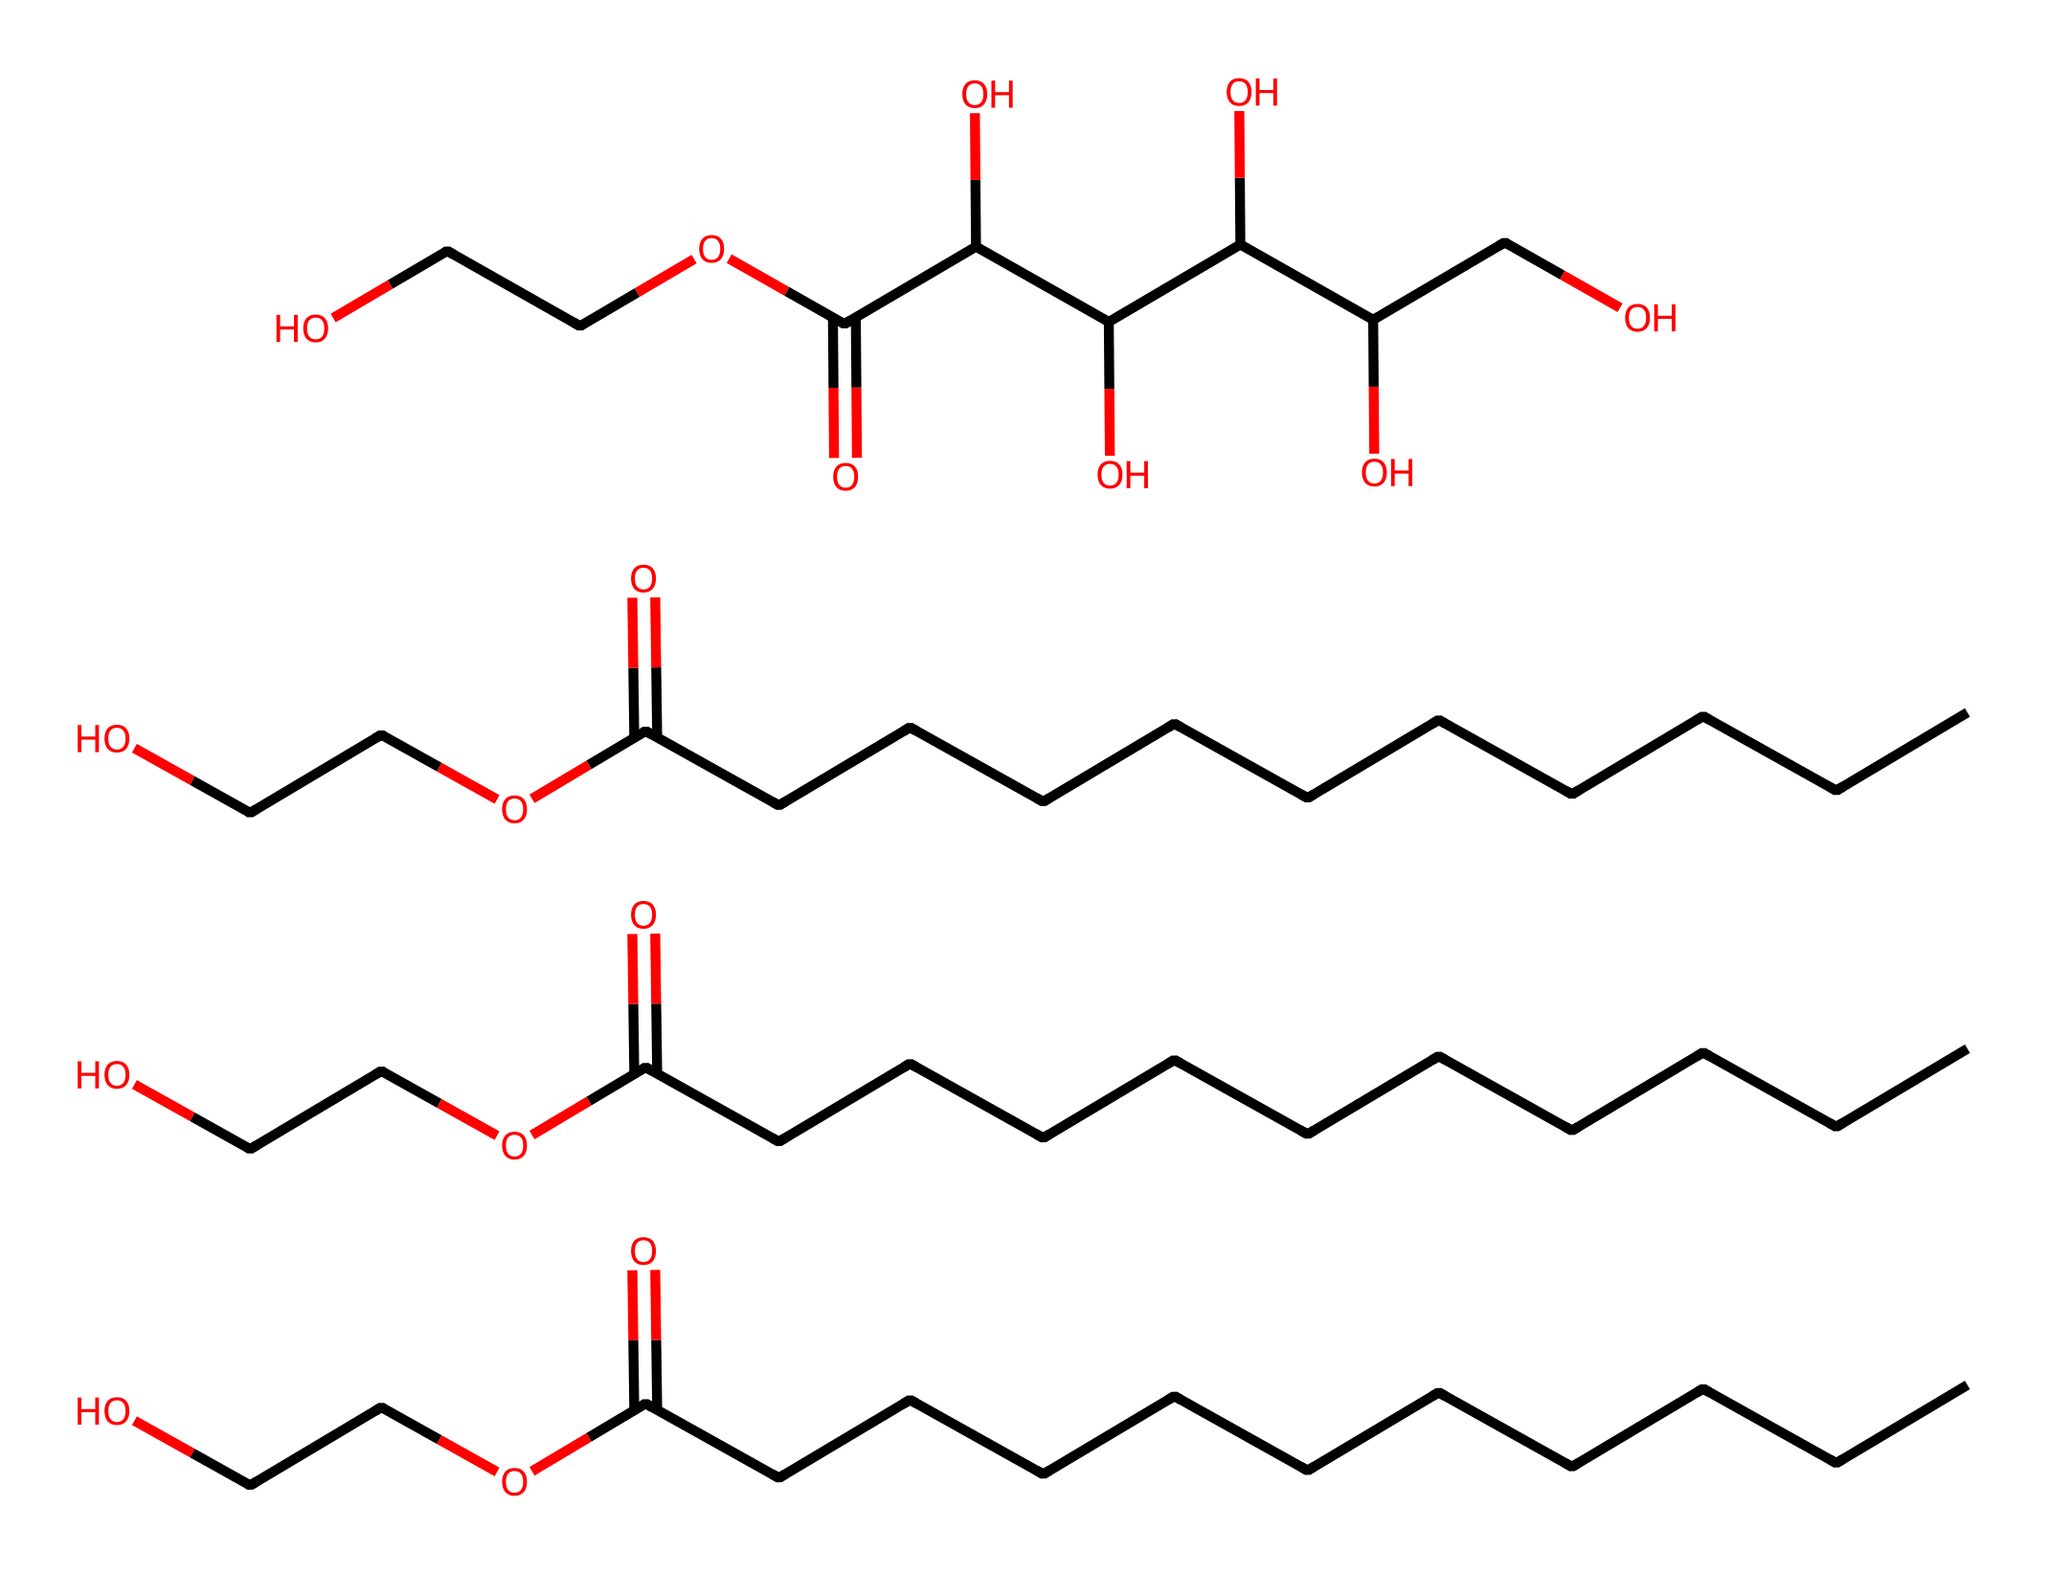What is the molecular formula of polysorbate 20? By interpreting the SMILES representation, we can see that multiple components represent the polysorbate structure. Counting the atoms represented in the structure, we gather that the elemental composition includes carbon, hydrogen, and oxygen. After compiling this information, the molecular formula is determined.
Answer: C58H114O26 How many hydroxyl (–OH) groups are present in this molecule? By analyzing the structure in the SMILES representation, we can identify parts of the molecule where hydroxyl groups are evident, which appear as branching where oxygen is linked to hydrogen atoms. A careful count reveals that there are six distinct hydroxyl groups in this polysorbate structure.
Answer: 6 What type of functional group characterizes polysorbate 20? Since polysorbate 20 is a surfactant, we look for characteristics in the chemical structure that denote surfactant behavior. The ester and hydroxyl functional groups present play a crucial role in determining the compound's amphiphilic nature, which is a defining feature of surfactants like polysorbate 20.
Answer: ester and hydroxyl How many carbon chains are attached to the main structure? In the SMILES depiction, we observe that the main molecular structure is connected by several carbon chains. By dissecting the structure step-by-step and following the SMILES notation, it is clear that there are three specific linear carbon chains attached to the central structure of polysorbate 20.
Answer: 3 What property makes polysorbate 20 effective as a surfactant in food applications? The effectiveness of polysorbate 20 as a surfactant stems from its amphiphilic nature, which allows it to reduce surface tension and stabilize emulsions. This property is inferred from the structural presence of both hydrophilic (due to hydroxyl groups) and hydrophobic (long carbon chains) components within the chemical's arrangement.
Answer: amphiphilic nature 